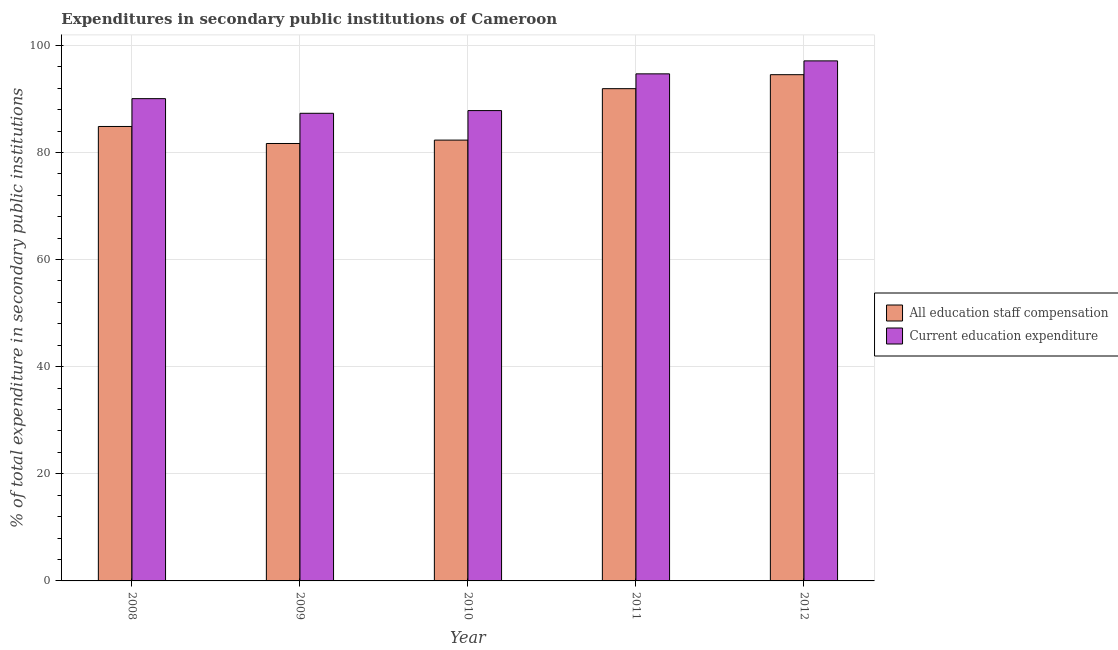How many different coloured bars are there?
Your response must be concise. 2. Are the number of bars per tick equal to the number of legend labels?
Make the answer very short. Yes. In how many cases, is the number of bars for a given year not equal to the number of legend labels?
Offer a terse response. 0. What is the expenditure in staff compensation in 2011?
Offer a terse response. 91.9. Across all years, what is the maximum expenditure in education?
Keep it short and to the point. 97.09. Across all years, what is the minimum expenditure in staff compensation?
Your answer should be compact. 81.67. In which year was the expenditure in education maximum?
Offer a terse response. 2012. What is the total expenditure in staff compensation in the graph?
Make the answer very short. 435.24. What is the difference between the expenditure in staff compensation in 2008 and that in 2011?
Keep it short and to the point. -7.06. What is the difference between the expenditure in education in 2011 and the expenditure in staff compensation in 2008?
Give a very brief answer. 4.63. What is the average expenditure in staff compensation per year?
Your answer should be very brief. 87.05. In how many years, is the expenditure in staff compensation greater than 12 %?
Provide a short and direct response. 5. What is the ratio of the expenditure in education in 2009 to that in 2010?
Keep it short and to the point. 0.99. Is the difference between the expenditure in education in 2008 and 2011 greater than the difference between the expenditure in staff compensation in 2008 and 2011?
Provide a succinct answer. No. What is the difference between the highest and the second highest expenditure in staff compensation?
Ensure brevity in your answer.  2.61. What is the difference between the highest and the lowest expenditure in education?
Make the answer very short. 9.78. In how many years, is the expenditure in staff compensation greater than the average expenditure in staff compensation taken over all years?
Provide a short and direct response. 2. Is the sum of the expenditure in education in 2008 and 2010 greater than the maximum expenditure in staff compensation across all years?
Provide a succinct answer. Yes. What does the 1st bar from the left in 2011 represents?
Ensure brevity in your answer.  All education staff compensation. What does the 1st bar from the right in 2008 represents?
Offer a terse response. Current education expenditure. Are all the bars in the graph horizontal?
Make the answer very short. No. What is the difference between two consecutive major ticks on the Y-axis?
Offer a very short reply. 20. Are the values on the major ticks of Y-axis written in scientific E-notation?
Provide a short and direct response. No. Where does the legend appear in the graph?
Offer a very short reply. Center right. How are the legend labels stacked?
Provide a short and direct response. Vertical. What is the title of the graph?
Make the answer very short. Expenditures in secondary public institutions of Cameroon. Does "Net National savings" appear as one of the legend labels in the graph?
Your answer should be compact. No. What is the label or title of the Y-axis?
Make the answer very short. % of total expenditure in secondary public institutions. What is the % of total expenditure in secondary public institutions of All education staff compensation in 2008?
Ensure brevity in your answer.  84.84. What is the % of total expenditure in secondary public institutions of Current education expenditure in 2008?
Ensure brevity in your answer.  90.04. What is the % of total expenditure in secondary public institutions in All education staff compensation in 2009?
Provide a short and direct response. 81.67. What is the % of total expenditure in secondary public institutions in Current education expenditure in 2009?
Offer a terse response. 87.31. What is the % of total expenditure in secondary public institutions of All education staff compensation in 2010?
Offer a very short reply. 82.3. What is the % of total expenditure in secondary public institutions in Current education expenditure in 2010?
Keep it short and to the point. 87.81. What is the % of total expenditure in secondary public institutions of All education staff compensation in 2011?
Offer a terse response. 91.9. What is the % of total expenditure in secondary public institutions in Current education expenditure in 2011?
Your response must be concise. 94.67. What is the % of total expenditure in secondary public institutions in All education staff compensation in 2012?
Keep it short and to the point. 94.52. What is the % of total expenditure in secondary public institutions in Current education expenditure in 2012?
Ensure brevity in your answer.  97.09. Across all years, what is the maximum % of total expenditure in secondary public institutions of All education staff compensation?
Give a very brief answer. 94.52. Across all years, what is the maximum % of total expenditure in secondary public institutions of Current education expenditure?
Provide a succinct answer. 97.09. Across all years, what is the minimum % of total expenditure in secondary public institutions in All education staff compensation?
Your answer should be compact. 81.67. Across all years, what is the minimum % of total expenditure in secondary public institutions of Current education expenditure?
Your answer should be compact. 87.31. What is the total % of total expenditure in secondary public institutions in All education staff compensation in the graph?
Your answer should be compact. 435.24. What is the total % of total expenditure in secondary public institutions in Current education expenditure in the graph?
Provide a succinct answer. 456.93. What is the difference between the % of total expenditure in secondary public institutions in All education staff compensation in 2008 and that in 2009?
Ensure brevity in your answer.  3.18. What is the difference between the % of total expenditure in secondary public institutions in Current education expenditure in 2008 and that in 2009?
Give a very brief answer. 2.73. What is the difference between the % of total expenditure in secondary public institutions of All education staff compensation in 2008 and that in 2010?
Provide a short and direct response. 2.54. What is the difference between the % of total expenditure in secondary public institutions of Current education expenditure in 2008 and that in 2010?
Ensure brevity in your answer.  2.23. What is the difference between the % of total expenditure in secondary public institutions in All education staff compensation in 2008 and that in 2011?
Offer a terse response. -7.06. What is the difference between the % of total expenditure in secondary public institutions of Current education expenditure in 2008 and that in 2011?
Give a very brief answer. -4.63. What is the difference between the % of total expenditure in secondary public institutions of All education staff compensation in 2008 and that in 2012?
Ensure brevity in your answer.  -9.67. What is the difference between the % of total expenditure in secondary public institutions of Current education expenditure in 2008 and that in 2012?
Give a very brief answer. -7.05. What is the difference between the % of total expenditure in secondary public institutions in All education staff compensation in 2009 and that in 2010?
Keep it short and to the point. -0.63. What is the difference between the % of total expenditure in secondary public institutions in Current education expenditure in 2009 and that in 2010?
Your answer should be compact. -0.5. What is the difference between the % of total expenditure in secondary public institutions of All education staff compensation in 2009 and that in 2011?
Make the answer very short. -10.24. What is the difference between the % of total expenditure in secondary public institutions in Current education expenditure in 2009 and that in 2011?
Your response must be concise. -7.36. What is the difference between the % of total expenditure in secondary public institutions in All education staff compensation in 2009 and that in 2012?
Your answer should be compact. -12.85. What is the difference between the % of total expenditure in secondary public institutions in Current education expenditure in 2009 and that in 2012?
Your answer should be compact. -9.78. What is the difference between the % of total expenditure in secondary public institutions of All education staff compensation in 2010 and that in 2011?
Give a very brief answer. -9.6. What is the difference between the % of total expenditure in secondary public institutions in Current education expenditure in 2010 and that in 2011?
Provide a succinct answer. -6.86. What is the difference between the % of total expenditure in secondary public institutions of All education staff compensation in 2010 and that in 2012?
Give a very brief answer. -12.21. What is the difference between the % of total expenditure in secondary public institutions in Current education expenditure in 2010 and that in 2012?
Provide a short and direct response. -9.28. What is the difference between the % of total expenditure in secondary public institutions of All education staff compensation in 2011 and that in 2012?
Your response must be concise. -2.61. What is the difference between the % of total expenditure in secondary public institutions of Current education expenditure in 2011 and that in 2012?
Give a very brief answer. -2.42. What is the difference between the % of total expenditure in secondary public institutions of All education staff compensation in 2008 and the % of total expenditure in secondary public institutions of Current education expenditure in 2009?
Keep it short and to the point. -2.46. What is the difference between the % of total expenditure in secondary public institutions in All education staff compensation in 2008 and the % of total expenditure in secondary public institutions in Current education expenditure in 2010?
Offer a terse response. -2.97. What is the difference between the % of total expenditure in secondary public institutions in All education staff compensation in 2008 and the % of total expenditure in secondary public institutions in Current education expenditure in 2011?
Keep it short and to the point. -9.83. What is the difference between the % of total expenditure in secondary public institutions of All education staff compensation in 2008 and the % of total expenditure in secondary public institutions of Current education expenditure in 2012?
Keep it short and to the point. -12.25. What is the difference between the % of total expenditure in secondary public institutions in All education staff compensation in 2009 and the % of total expenditure in secondary public institutions in Current education expenditure in 2010?
Provide a short and direct response. -6.14. What is the difference between the % of total expenditure in secondary public institutions in All education staff compensation in 2009 and the % of total expenditure in secondary public institutions in Current education expenditure in 2011?
Your answer should be very brief. -13. What is the difference between the % of total expenditure in secondary public institutions in All education staff compensation in 2009 and the % of total expenditure in secondary public institutions in Current education expenditure in 2012?
Your answer should be very brief. -15.42. What is the difference between the % of total expenditure in secondary public institutions of All education staff compensation in 2010 and the % of total expenditure in secondary public institutions of Current education expenditure in 2011?
Provide a short and direct response. -12.37. What is the difference between the % of total expenditure in secondary public institutions of All education staff compensation in 2010 and the % of total expenditure in secondary public institutions of Current education expenditure in 2012?
Ensure brevity in your answer.  -14.79. What is the difference between the % of total expenditure in secondary public institutions of All education staff compensation in 2011 and the % of total expenditure in secondary public institutions of Current education expenditure in 2012?
Give a very brief answer. -5.19. What is the average % of total expenditure in secondary public institutions in All education staff compensation per year?
Offer a very short reply. 87.05. What is the average % of total expenditure in secondary public institutions of Current education expenditure per year?
Your answer should be very brief. 91.39. In the year 2008, what is the difference between the % of total expenditure in secondary public institutions in All education staff compensation and % of total expenditure in secondary public institutions in Current education expenditure?
Your response must be concise. -5.2. In the year 2009, what is the difference between the % of total expenditure in secondary public institutions of All education staff compensation and % of total expenditure in secondary public institutions of Current education expenditure?
Your response must be concise. -5.64. In the year 2010, what is the difference between the % of total expenditure in secondary public institutions of All education staff compensation and % of total expenditure in secondary public institutions of Current education expenditure?
Your answer should be very brief. -5.51. In the year 2011, what is the difference between the % of total expenditure in secondary public institutions in All education staff compensation and % of total expenditure in secondary public institutions in Current education expenditure?
Provide a short and direct response. -2.77. In the year 2012, what is the difference between the % of total expenditure in secondary public institutions in All education staff compensation and % of total expenditure in secondary public institutions in Current education expenditure?
Offer a very short reply. -2.58. What is the ratio of the % of total expenditure in secondary public institutions of All education staff compensation in 2008 to that in 2009?
Provide a short and direct response. 1.04. What is the ratio of the % of total expenditure in secondary public institutions of Current education expenditure in 2008 to that in 2009?
Make the answer very short. 1.03. What is the ratio of the % of total expenditure in secondary public institutions in All education staff compensation in 2008 to that in 2010?
Provide a succinct answer. 1.03. What is the ratio of the % of total expenditure in secondary public institutions in Current education expenditure in 2008 to that in 2010?
Provide a short and direct response. 1.03. What is the ratio of the % of total expenditure in secondary public institutions of All education staff compensation in 2008 to that in 2011?
Offer a terse response. 0.92. What is the ratio of the % of total expenditure in secondary public institutions of Current education expenditure in 2008 to that in 2011?
Give a very brief answer. 0.95. What is the ratio of the % of total expenditure in secondary public institutions of All education staff compensation in 2008 to that in 2012?
Keep it short and to the point. 0.9. What is the ratio of the % of total expenditure in secondary public institutions of Current education expenditure in 2008 to that in 2012?
Offer a very short reply. 0.93. What is the ratio of the % of total expenditure in secondary public institutions in All education staff compensation in 2009 to that in 2011?
Offer a very short reply. 0.89. What is the ratio of the % of total expenditure in secondary public institutions in Current education expenditure in 2009 to that in 2011?
Provide a succinct answer. 0.92. What is the ratio of the % of total expenditure in secondary public institutions in All education staff compensation in 2009 to that in 2012?
Ensure brevity in your answer.  0.86. What is the ratio of the % of total expenditure in secondary public institutions of Current education expenditure in 2009 to that in 2012?
Keep it short and to the point. 0.9. What is the ratio of the % of total expenditure in secondary public institutions in All education staff compensation in 2010 to that in 2011?
Your response must be concise. 0.9. What is the ratio of the % of total expenditure in secondary public institutions in Current education expenditure in 2010 to that in 2011?
Provide a succinct answer. 0.93. What is the ratio of the % of total expenditure in secondary public institutions of All education staff compensation in 2010 to that in 2012?
Make the answer very short. 0.87. What is the ratio of the % of total expenditure in secondary public institutions in Current education expenditure in 2010 to that in 2012?
Offer a terse response. 0.9. What is the ratio of the % of total expenditure in secondary public institutions in All education staff compensation in 2011 to that in 2012?
Provide a succinct answer. 0.97. What is the ratio of the % of total expenditure in secondary public institutions in Current education expenditure in 2011 to that in 2012?
Your answer should be very brief. 0.98. What is the difference between the highest and the second highest % of total expenditure in secondary public institutions of All education staff compensation?
Your answer should be very brief. 2.61. What is the difference between the highest and the second highest % of total expenditure in secondary public institutions of Current education expenditure?
Provide a short and direct response. 2.42. What is the difference between the highest and the lowest % of total expenditure in secondary public institutions in All education staff compensation?
Keep it short and to the point. 12.85. What is the difference between the highest and the lowest % of total expenditure in secondary public institutions of Current education expenditure?
Offer a very short reply. 9.78. 